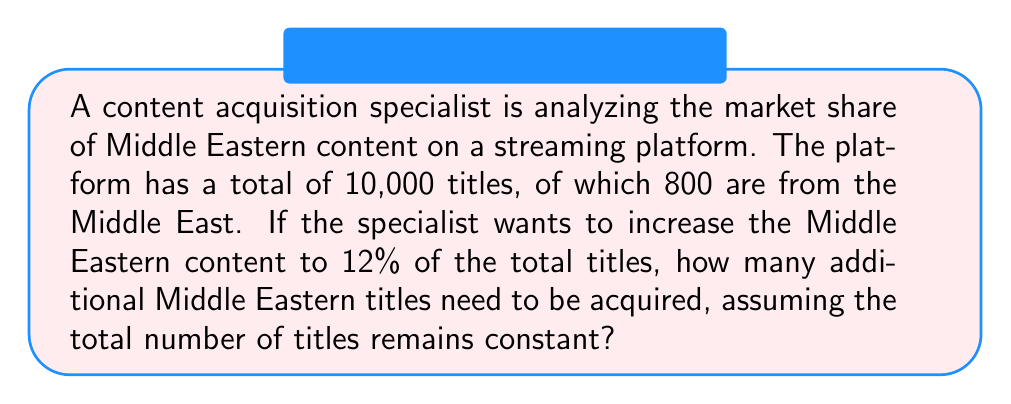What is the answer to this math problem? Let's approach this step-by-step:

1. Calculate the current market share of Middle Eastern content:
   Current share = $\frac{\text{Middle Eastern titles}}{\text{Total titles}} \times 100\%$
   $$ \frac{800}{10,000} \times 100\% = 8\% $$

2. Calculate the number of Middle Eastern titles needed for 12% market share:
   $$ 0.12 \times 10,000 = 1,200 \text{ titles} $$

3. Calculate the difference between the desired number and the current number:
   $$ 1,200 - 800 = 400 \text{ titles} $$

Therefore, the content acquisition specialist needs to acquire 400 additional Middle Eastern titles to reach the 12% market share goal.
Answer: 400 titles 